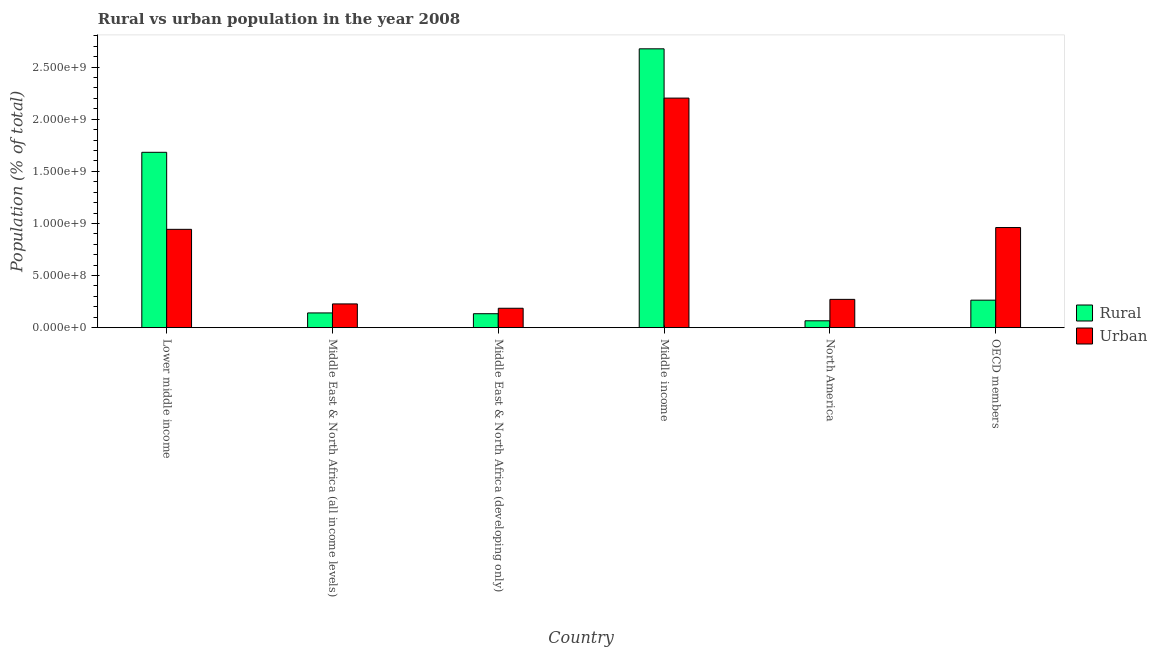How many different coloured bars are there?
Provide a short and direct response. 2. Are the number of bars on each tick of the X-axis equal?
Offer a very short reply. Yes. How many bars are there on the 5th tick from the left?
Provide a short and direct response. 2. What is the label of the 3rd group of bars from the left?
Provide a succinct answer. Middle East & North Africa (developing only). In how many cases, is the number of bars for a given country not equal to the number of legend labels?
Give a very brief answer. 0. What is the urban population density in Lower middle income?
Ensure brevity in your answer.  9.43e+08. Across all countries, what is the maximum urban population density?
Your answer should be very brief. 2.20e+09. Across all countries, what is the minimum rural population density?
Make the answer very short. 6.59e+07. What is the total urban population density in the graph?
Provide a succinct answer. 4.79e+09. What is the difference between the rural population density in North America and that in OECD members?
Your response must be concise. -1.98e+08. What is the difference between the urban population density in Middle income and the rural population density in Middle East & North Africa (developing only)?
Ensure brevity in your answer.  2.07e+09. What is the average urban population density per country?
Offer a terse response. 7.99e+08. What is the difference between the urban population density and rural population density in Middle income?
Provide a succinct answer. -4.73e+08. What is the ratio of the rural population density in Lower middle income to that in North America?
Provide a short and direct response. 25.51. What is the difference between the highest and the second highest urban population density?
Offer a very short reply. 1.24e+09. What is the difference between the highest and the lowest urban population density?
Your answer should be very brief. 2.02e+09. In how many countries, is the rural population density greater than the average rural population density taken over all countries?
Your response must be concise. 2. What does the 2nd bar from the left in Middle income represents?
Your answer should be very brief. Urban. What does the 2nd bar from the right in Lower middle income represents?
Provide a short and direct response. Rural. How many bars are there?
Keep it short and to the point. 12. Does the graph contain any zero values?
Keep it short and to the point. No. Does the graph contain grids?
Your answer should be very brief. No. What is the title of the graph?
Your response must be concise. Rural vs urban population in the year 2008. Does "Overweight" appear as one of the legend labels in the graph?
Provide a short and direct response. No. What is the label or title of the X-axis?
Your answer should be compact. Country. What is the label or title of the Y-axis?
Your answer should be very brief. Population (% of total). What is the Population (% of total) of Rural in Lower middle income?
Ensure brevity in your answer.  1.68e+09. What is the Population (% of total) in Urban in Lower middle income?
Your answer should be compact. 9.43e+08. What is the Population (% of total) in Rural in Middle East & North Africa (all income levels)?
Your response must be concise. 1.41e+08. What is the Population (% of total) of Urban in Middle East & North Africa (all income levels)?
Offer a very short reply. 2.28e+08. What is the Population (% of total) in Rural in Middle East & North Africa (developing only)?
Your answer should be very brief. 1.34e+08. What is the Population (% of total) in Urban in Middle East & North Africa (developing only)?
Give a very brief answer. 1.86e+08. What is the Population (% of total) in Rural in Middle income?
Give a very brief answer. 2.68e+09. What is the Population (% of total) in Urban in Middle income?
Your response must be concise. 2.20e+09. What is the Population (% of total) in Rural in North America?
Your answer should be very brief. 6.59e+07. What is the Population (% of total) of Urban in North America?
Provide a short and direct response. 2.71e+08. What is the Population (% of total) in Rural in OECD members?
Make the answer very short. 2.64e+08. What is the Population (% of total) of Urban in OECD members?
Offer a very short reply. 9.61e+08. Across all countries, what is the maximum Population (% of total) in Rural?
Offer a terse response. 2.68e+09. Across all countries, what is the maximum Population (% of total) in Urban?
Ensure brevity in your answer.  2.20e+09. Across all countries, what is the minimum Population (% of total) in Rural?
Offer a terse response. 6.59e+07. Across all countries, what is the minimum Population (% of total) in Urban?
Keep it short and to the point. 1.86e+08. What is the total Population (% of total) in Rural in the graph?
Your response must be concise. 4.96e+09. What is the total Population (% of total) in Urban in the graph?
Offer a very short reply. 4.79e+09. What is the difference between the Population (% of total) in Rural in Lower middle income and that in Middle East & North Africa (all income levels)?
Provide a short and direct response. 1.54e+09. What is the difference between the Population (% of total) of Urban in Lower middle income and that in Middle East & North Africa (all income levels)?
Your answer should be very brief. 7.15e+08. What is the difference between the Population (% of total) in Rural in Lower middle income and that in Middle East & North Africa (developing only)?
Ensure brevity in your answer.  1.55e+09. What is the difference between the Population (% of total) in Urban in Lower middle income and that in Middle East & North Africa (developing only)?
Your response must be concise. 7.57e+08. What is the difference between the Population (% of total) of Rural in Lower middle income and that in Middle income?
Offer a terse response. -9.93e+08. What is the difference between the Population (% of total) in Urban in Lower middle income and that in Middle income?
Offer a terse response. -1.26e+09. What is the difference between the Population (% of total) in Rural in Lower middle income and that in North America?
Offer a very short reply. 1.62e+09. What is the difference between the Population (% of total) in Urban in Lower middle income and that in North America?
Ensure brevity in your answer.  6.72e+08. What is the difference between the Population (% of total) of Rural in Lower middle income and that in OECD members?
Ensure brevity in your answer.  1.42e+09. What is the difference between the Population (% of total) of Urban in Lower middle income and that in OECD members?
Keep it short and to the point. -1.73e+07. What is the difference between the Population (% of total) of Rural in Middle East & North Africa (all income levels) and that in Middle East & North Africa (developing only)?
Your answer should be compact. 7.57e+06. What is the difference between the Population (% of total) in Urban in Middle East & North Africa (all income levels) and that in Middle East & North Africa (developing only)?
Provide a short and direct response. 4.17e+07. What is the difference between the Population (% of total) of Rural in Middle East & North Africa (all income levels) and that in Middle income?
Provide a succinct answer. -2.53e+09. What is the difference between the Population (% of total) in Urban in Middle East & North Africa (all income levels) and that in Middle income?
Provide a short and direct response. -1.97e+09. What is the difference between the Population (% of total) in Rural in Middle East & North Africa (all income levels) and that in North America?
Your response must be concise. 7.54e+07. What is the difference between the Population (% of total) in Urban in Middle East & North Africa (all income levels) and that in North America?
Make the answer very short. -4.36e+07. What is the difference between the Population (% of total) of Rural in Middle East & North Africa (all income levels) and that in OECD members?
Your answer should be very brief. -1.23e+08. What is the difference between the Population (% of total) of Urban in Middle East & North Africa (all income levels) and that in OECD members?
Keep it short and to the point. -7.33e+08. What is the difference between the Population (% of total) of Rural in Middle East & North Africa (developing only) and that in Middle income?
Keep it short and to the point. -2.54e+09. What is the difference between the Population (% of total) of Urban in Middle East & North Africa (developing only) and that in Middle income?
Your response must be concise. -2.02e+09. What is the difference between the Population (% of total) of Rural in Middle East & North Africa (developing only) and that in North America?
Your response must be concise. 6.78e+07. What is the difference between the Population (% of total) of Urban in Middle East & North Africa (developing only) and that in North America?
Your answer should be compact. -8.52e+07. What is the difference between the Population (% of total) of Rural in Middle East & North Africa (developing only) and that in OECD members?
Your answer should be compact. -1.30e+08. What is the difference between the Population (% of total) of Urban in Middle East & North Africa (developing only) and that in OECD members?
Your answer should be very brief. -7.74e+08. What is the difference between the Population (% of total) in Rural in Middle income and that in North America?
Provide a short and direct response. 2.61e+09. What is the difference between the Population (% of total) in Urban in Middle income and that in North America?
Give a very brief answer. 1.93e+09. What is the difference between the Population (% of total) in Rural in Middle income and that in OECD members?
Your answer should be compact. 2.41e+09. What is the difference between the Population (% of total) in Urban in Middle income and that in OECD members?
Your answer should be compact. 1.24e+09. What is the difference between the Population (% of total) in Rural in North America and that in OECD members?
Provide a short and direct response. -1.98e+08. What is the difference between the Population (% of total) in Urban in North America and that in OECD members?
Give a very brief answer. -6.89e+08. What is the difference between the Population (% of total) of Rural in Lower middle income and the Population (% of total) of Urban in Middle East & North Africa (all income levels)?
Give a very brief answer. 1.45e+09. What is the difference between the Population (% of total) in Rural in Lower middle income and the Population (% of total) in Urban in Middle East & North Africa (developing only)?
Your answer should be compact. 1.50e+09. What is the difference between the Population (% of total) in Rural in Lower middle income and the Population (% of total) in Urban in Middle income?
Your answer should be very brief. -5.20e+08. What is the difference between the Population (% of total) in Rural in Lower middle income and the Population (% of total) in Urban in North America?
Offer a very short reply. 1.41e+09. What is the difference between the Population (% of total) in Rural in Lower middle income and the Population (% of total) in Urban in OECD members?
Make the answer very short. 7.22e+08. What is the difference between the Population (% of total) of Rural in Middle East & North Africa (all income levels) and the Population (% of total) of Urban in Middle East & North Africa (developing only)?
Provide a succinct answer. -4.49e+07. What is the difference between the Population (% of total) in Rural in Middle East & North Africa (all income levels) and the Population (% of total) in Urban in Middle income?
Keep it short and to the point. -2.06e+09. What is the difference between the Population (% of total) of Rural in Middle East & North Africa (all income levels) and the Population (% of total) of Urban in North America?
Your response must be concise. -1.30e+08. What is the difference between the Population (% of total) in Rural in Middle East & North Africa (all income levels) and the Population (% of total) in Urban in OECD members?
Give a very brief answer. -8.19e+08. What is the difference between the Population (% of total) of Rural in Middle East & North Africa (developing only) and the Population (% of total) of Urban in Middle income?
Offer a terse response. -2.07e+09. What is the difference between the Population (% of total) in Rural in Middle East & North Africa (developing only) and the Population (% of total) in Urban in North America?
Your answer should be compact. -1.38e+08. What is the difference between the Population (% of total) of Rural in Middle East & North Africa (developing only) and the Population (% of total) of Urban in OECD members?
Keep it short and to the point. -8.27e+08. What is the difference between the Population (% of total) in Rural in Middle income and the Population (% of total) in Urban in North America?
Ensure brevity in your answer.  2.40e+09. What is the difference between the Population (% of total) in Rural in Middle income and the Population (% of total) in Urban in OECD members?
Offer a very short reply. 1.71e+09. What is the difference between the Population (% of total) in Rural in North America and the Population (% of total) in Urban in OECD members?
Your response must be concise. -8.95e+08. What is the average Population (% of total) of Rural per country?
Make the answer very short. 8.27e+08. What is the average Population (% of total) of Urban per country?
Your answer should be very brief. 7.99e+08. What is the difference between the Population (% of total) of Rural and Population (% of total) of Urban in Lower middle income?
Your answer should be compact. 7.39e+08. What is the difference between the Population (% of total) in Rural and Population (% of total) in Urban in Middle East & North Africa (all income levels)?
Make the answer very short. -8.65e+07. What is the difference between the Population (% of total) in Rural and Population (% of total) in Urban in Middle East & North Africa (developing only)?
Ensure brevity in your answer.  -5.24e+07. What is the difference between the Population (% of total) of Rural and Population (% of total) of Urban in Middle income?
Give a very brief answer. 4.73e+08. What is the difference between the Population (% of total) of Rural and Population (% of total) of Urban in North America?
Offer a very short reply. -2.06e+08. What is the difference between the Population (% of total) in Rural and Population (% of total) in Urban in OECD members?
Ensure brevity in your answer.  -6.97e+08. What is the ratio of the Population (% of total) in Rural in Lower middle income to that in Middle East & North Africa (all income levels)?
Provide a succinct answer. 11.9. What is the ratio of the Population (% of total) in Urban in Lower middle income to that in Middle East & North Africa (all income levels)?
Offer a terse response. 4.14. What is the ratio of the Population (% of total) of Rural in Lower middle income to that in Middle East & North Africa (developing only)?
Your answer should be compact. 12.57. What is the ratio of the Population (% of total) in Urban in Lower middle income to that in Middle East & North Africa (developing only)?
Ensure brevity in your answer.  5.07. What is the ratio of the Population (% of total) of Rural in Lower middle income to that in Middle income?
Give a very brief answer. 0.63. What is the ratio of the Population (% of total) of Urban in Lower middle income to that in Middle income?
Your response must be concise. 0.43. What is the ratio of the Population (% of total) in Rural in Lower middle income to that in North America?
Offer a very short reply. 25.51. What is the ratio of the Population (% of total) of Urban in Lower middle income to that in North America?
Ensure brevity in your answer.  3.47. What is the ratio of the Population (% of total) of Rural in Lower middle income to that in OECD members?
Provide a short and direct response. 6.38. What is the ratio of the Population (% of total) in Urban in Lower middle income to that in OECD members?
Your response must be concise. 0.98. What is the ratio of the Population (% of total) in Rural in Middle East & North Africa (all income levels) to that in Middle East & North Africa (developing only)?
Your answer should be compact. 1.06. What is the ratio of the Population (% of total) of Urban in Middle East & North Africa (all income levels) to that in Middle East & North Africa (developing only)?
Your answer should be very brief. 1.22. What is the ratio of the Population (% of total) in Rural in Middle East & North Africa (all income levels) to that in Middle income?
Ensure brevity in your answer.  0.05. What is the ratio of the Population (% of total) in Urban in Middle East & North Africa (all income levels) to that in Middle income?
Provide a succinct answer. 0.1. What is the ratio of the Population (% of total) of Rural in Middle East & North Africa (all income levels) to that in North America?
Make the answer very short. 2.14. What is the ratio of the Population (% of total) in Urban in Middle East & North Africa (all income levels) to that in North America?
Your answer should be compact. 0.84. What is the ratio of the Population (% of total) in Rural in Middle East & North Africa (all income levels) to that in OECD members?
Give a very brief answer. 0.54. What is the ratio of the Population (% of total) in Urban in Middle East & North Africa (all income levels) to that in OECD members?
Make the answer very short. 0.24. What is the ratio of the Population (% of total) in Urban in Middle East & North Africa (developing only) to that in Middle income?
Provide a short and direct response. 0.08. What is the ratio of the Population (% of total) of Rural in Middle East & North Africa (developing only) to that in North America?
Offer a terse response. 2.03. What is the ratio of the Population (% of total) of Urban in Middle East & North Africa (developing only) to that in North America?
Provide a succinct answer. 0.69. What is the ratio of the Population (% of total) of Rural in Middle East & North Africa (developing only) to that in OECD members?
Your answer should be very brief. 0.51. What is the ratio of the Population (% of total) in Urban in Middle East & North Africa (developing only) to that in OECD members?
Provide a succinct answer. 0.19. What is the ratio of the Population (% of total) in Rural in Middle income to that in North America?
Provide a succinct answer. 40.57. What is the ratio of the Population (% of total) of Urban in Middle income to that in North America?
Give a very brief answer. 8.11. What is the ratio of the Population (% of total) in Rural in Middle income to that in OECD members?
Your answer should be compact. 10.14. What is the ratio of the Population (% of total) of Urban in Middle income to that in OECD members?
Offer a very short reply. 2.29. What is the ratio of the Population (% of total) of Rural in North America to that in OECD members?
Your answer should be compact. 0.25. What is the ratio of the Population (% of total) in Urban in North America to that in OECD members?
Give a very brief answer. 0.28. What is the difference between the highest and the second highest Population (% of total) in Rural?
Offer a terse response. 9.93e+08. What is the difference between the highest and the second highest Population (% of total) of Urban?
Offer a terse response. 1.24e+09. What is the difference between the highest and the lowest Population (% of total) in Rural?
Ensure brevity in your answer.  2.61e+09. What is the difference between the highest and the lowest Population (% of total) of Urban?
Ensure brevity in your answer.  2.02e+09. 